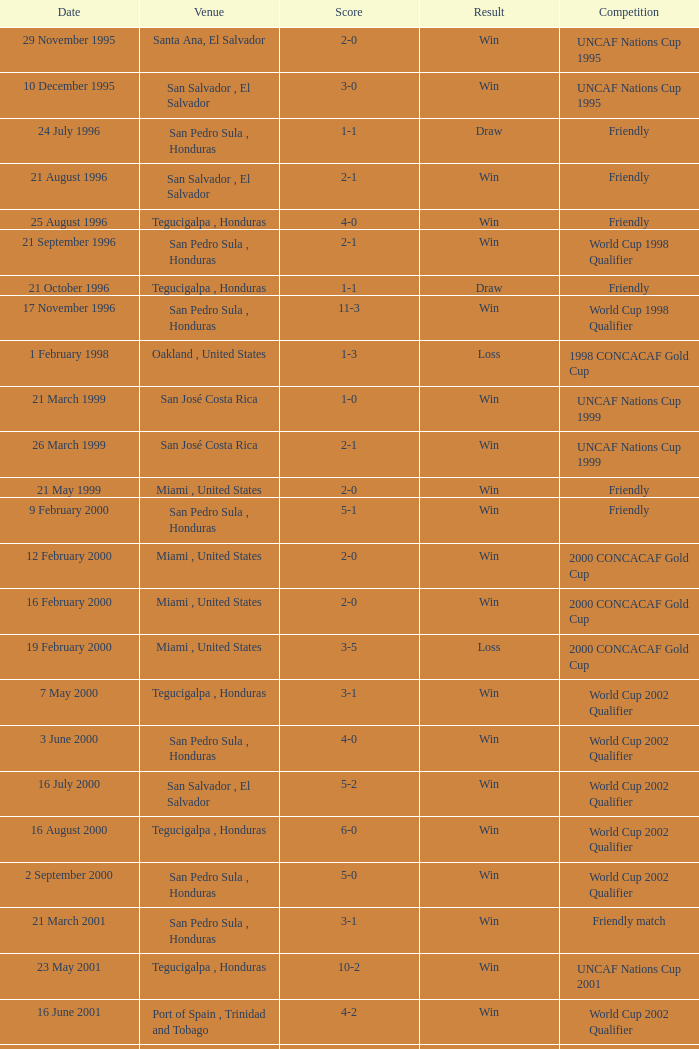On what date did the 2009 uncaf nations cup take place? 26 January 2009. 